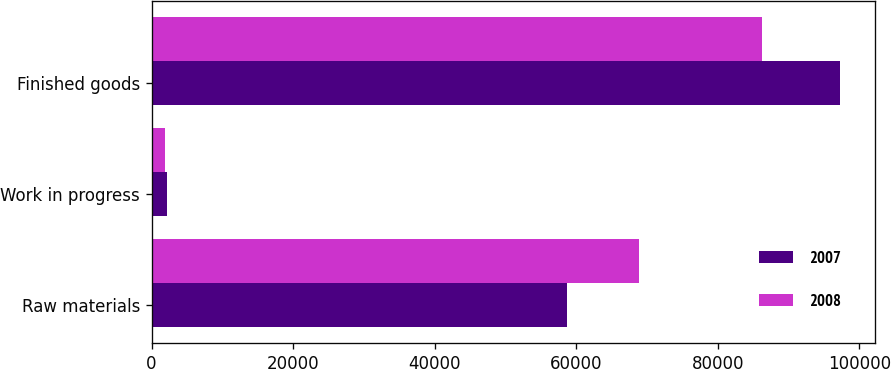<chart> <loc_0><loc_0><loc_500><loc_500><stacked_bar_chart><ecel><fcel>Raw materials<fcel>Work in progress<fcel>Finished goods<nl><fcel>2007<fcel>58768<fcel>2165<fcel>97318<nl><fcel>2008<fcel>68911<fcel>1965<fcel>86328<nl></chart> 